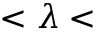<formula> <loc_0><loc_0><loc_500><loc_500>< \lambda <</formula> 